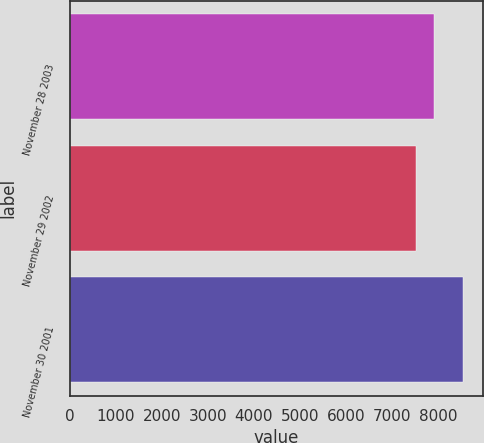<chart> <loc_0><loc_0><loc_500><loc_500><bar_chart><fcel>November 28 2003<fcel>November 29 2002<fcel>November 30 2001<nl><fcel>7903<fcel>7531<fcel>8549<nl></chart> 